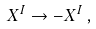Convert formula to latex. <formula><loc_0><loc_0><loc_500><loc_500>X ^ { I } \to - X ^ { I } \, ,</formula> 